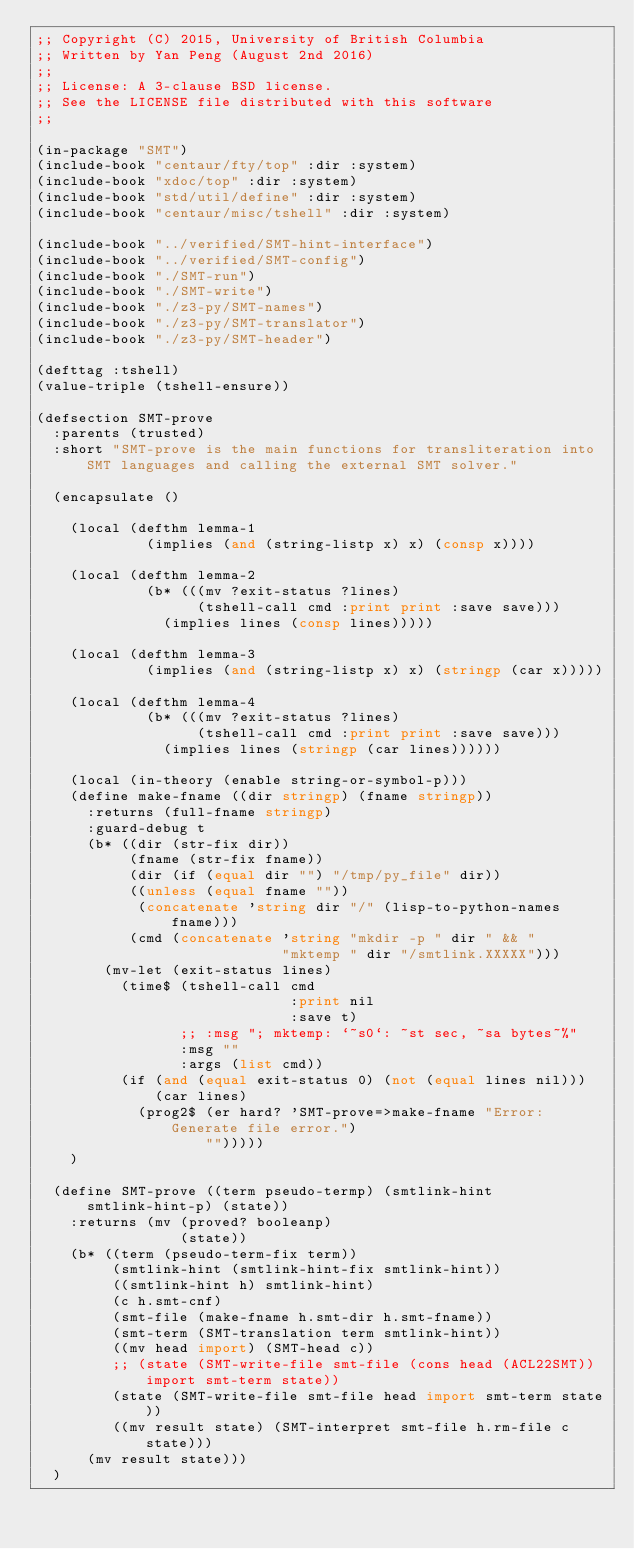Convert code to text. <code><loc_0><loc_0><loc_500><loc_500><_Lisp_>;; Copyright (C) 2015, University of British Columbia
;; Written by Yan Peng (August 2nd 2016)
;;
;; License: A 3-clause BSD license.
;; See the LICENSE file distributed with this software
;;

(in-package "SMT")
(include-book "centaur/fty/top" :dir :system)
(include-book "xdoc/top" :dir :system)
(include-book "std/util/define" :dir :system)
(include-book "centaur/misc/tshell" :dir :system)

(include-book "../verified/SMT-hint-interface")
(include-book "../verified/SMT-config")
(include-book "./SMT-run")
(include-book "./SMT-write")
(include-book "./z3-py/SMT-names")
(include-book "./z3-py/SMT-translator")
(include-book "./z3-py/SMT-header")

(defttag :tshell)
(value-triple (tshell-ensure))

(defsection SMT-prove
  :parents (trusted)
  :short "SMT-prove is the main functions for transliteration into SMT languages and calling the external SMT solver."

  (encapsulate ()

    (local (defthm lemma-1
             (implies (and (string-listp x) x) (consp x))))

    (local (defthm lemma-2
             (b* (((mv ?exit-status ?lines)
                   (tshell-call cmd :print print :save save)))
               (implies lines (consp lines)))))

    (local (defthm lemma-3
             (implies (and (string-listp x) x) (stringp (car x)))))

    (local (defthm lemma-4
             (b* (((mv ?exit-status ?lines)
                   (tshell-call cmd :print print :save save)))
               (implies lines (stringp (car lines))))))

    (local (in-theory (enable string-or-symbol-p)))
    (define make-fname ((dir stringp) (fname stringp))
      :returns (full-fname stringp)
      :guard-debug t
      (b* ((dir (str-fix dir))
           (fname (str-fix fname))
           (dir (if (equal dir "") "/tmp/py_file" dir))
           ((unless (equal fname ""))
            (concatenate 'string dir "/" (lisp-to-python-names fname)))
           (cmd (concatenate 'string "mkdir -p " dir " && "
                             "mktemp " dir "/smtlink.XXXXX")))
        (mv-let (exit-status lines)
          (time$ (tshell-call cmd
                              :print nil
                              :save t)
                 ;; :msg "; mktemp: `~s0`: ~st sec, ~sa bytes~%"
                 :msg ""
                 :args (list cmd))
          (if (and (equal exit-status 0) (not (equal lines nil)))
              (car lines)
            (prog2$ (er hard? 'SMT-prove=>make-fname "Error: Generate file error.")
                    "")))))
    )

  (define SMT-prove ((term pseudo-termp) (smtlink-hint smtlink-hint-p) (state))
    :returns (mv (proved? booleanp)
                 (state))
    (b* ((term (pseudo-term-fix term))
         (smtlink-hint (smtlink-hint-fix smtlink-hint))
         ((smtlink-hint h) smtlink-hint)
         (c h.smt-cnf)
         (smt-file (make-fname h.smt-dir h.smt-fname))
         (smt-term (SMT-translation term smtlink-hint))
         ((mv head import) (SMT-head c))
         ;; (state (SMT-write-file smt-file (cons head (ACL22SMT)) import smt-term state))
         (state (SMT-write-file smt-file head import smt-term state))
         ((mv result state) (SMT-interpret smt-file h.rm-file c state)))
      (mv result state)))
  )
</code> 